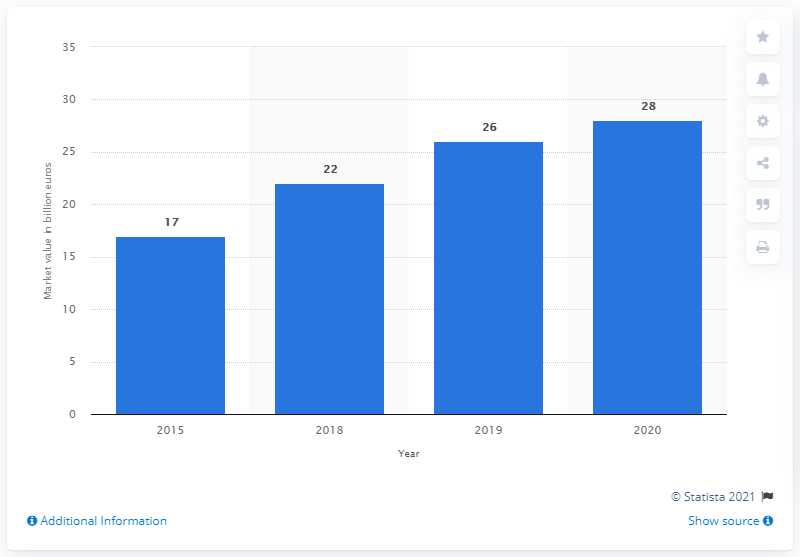Draw attention to some important aspects in this diagram. The average of all the bars is 23.5. The value of 2019 is 26... The second-hand personal luxury goods market in 2020 had a value of approximately 28... 